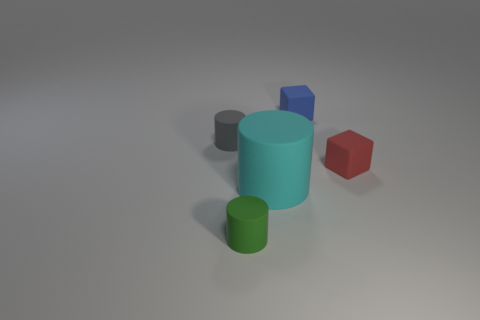There is a blue rubber block; is its size the same as the gray cylinder in front of the tiny blue object?
Offer a very short reply. Yes. How many objects are cyan shiny blocks or blue rubber objects?
Provide a succinct answer. 1. What number of tiny cubes are the same color as the big cylinder?
Your answer should be compact. 0. There is a red matte thing that is the same size as the blue block; what is its shape?
Make the answer very short. Cube. Is there a blue rubber object that has the same shape as the small red thing?
Ensure brevity in your answer.  Yes. What number of other small things have the same material as the blue object?
Your answer should be compact. 3. Are the cube right of the blue rubber block and the tiny blue cube made of the same material?
Your answer should be very brief. Yes. Is the number of small cubes that are behind the small red cube greater than the number of cyan objects that are behind the cyan cylinder?
Give a very brief answer. Yes. There is a green thing that is the same size as the blue cube; what is its material?
Provide a succinct answer. Rubber. What number of other objects are there of the same material as the small red object?
Make the answer very short. 4. 